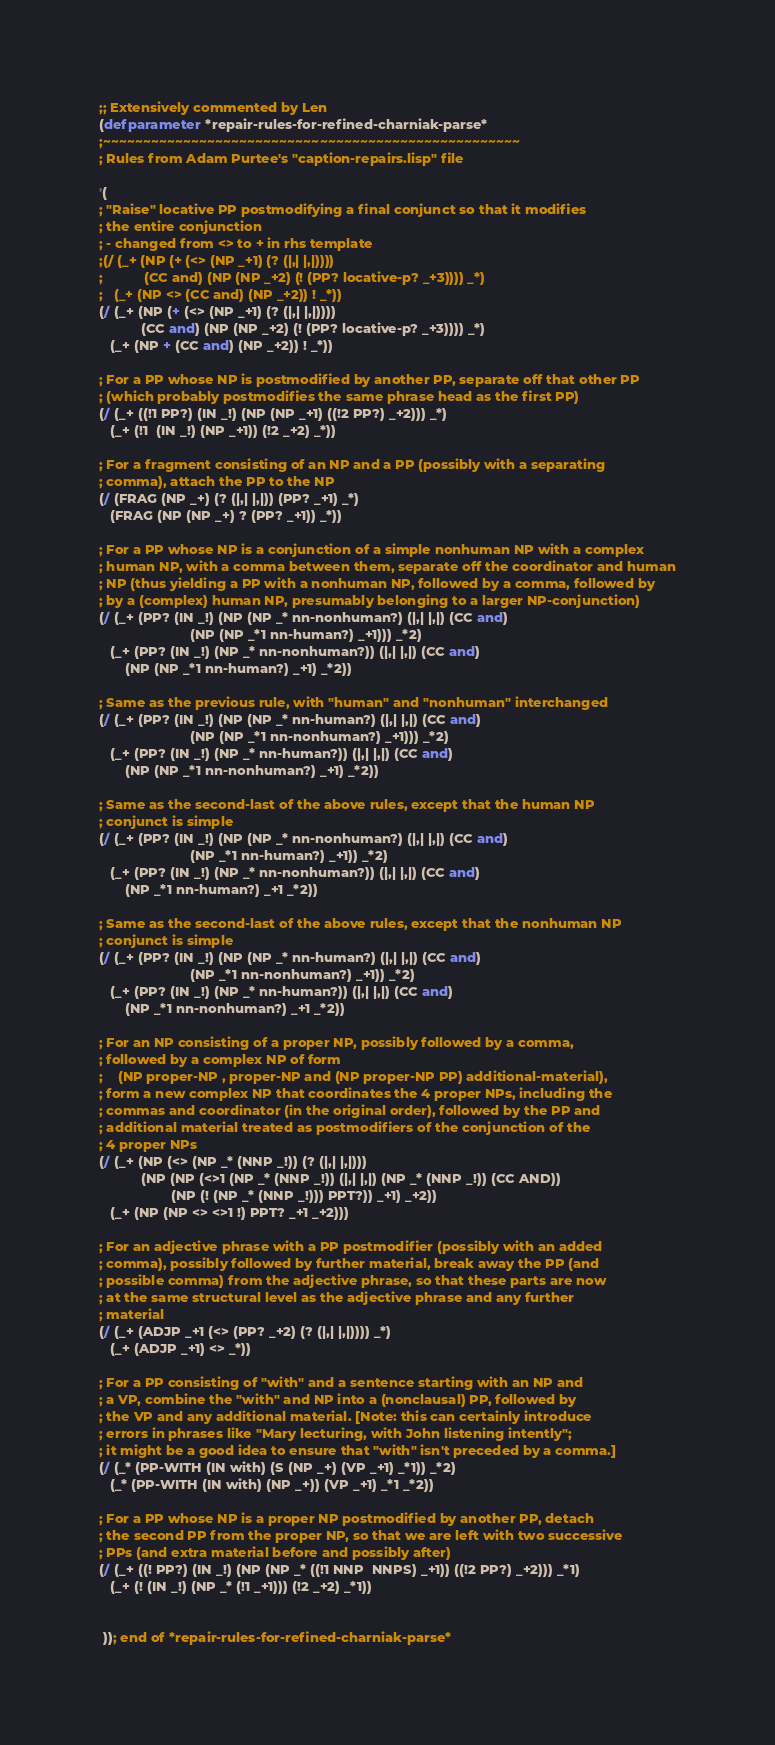<code> <loc_0><loc_0><loc_500><loc_500><_Lisp_>;; Extensively commented by Len 
(defparameter *repair-rules-for-refined-charniak-parse*
;~~~~~~~~~~~~~~~~~~~~~~~~~~~~~~~~~~~~~~~~~~~~~~~~~~~~
; Rules from Adam Purtee's "caption-repairs.lisp" file

'(
; "Raise" locative PP postmodifying a final conjunct so that it modifies
; the entire conjunction 
; - changed from <> to + in rhs template
;(/ (_+ (NP (+ (<> (NP _+1) (? (|,| |,|)))) 
;           (CC and) (NP (NP _+2) (! (PP? locative-p? _+3)))) _*) 
;   (_+ (NP <> (CC and) (NP _+2)) ! _*))
(/ (_+ (NP (+ (<> (NP _+1) (? (|,| |,|)))) 
           (CC and) (NP (NP _+2) (! (PP? locative-p? _+3)))) _*) 
   (_+ (NP + (CC and) (NP _+2)) ! _*))

; For a PP whose NP is postmodified by another PP, separate off that other PP
; (which probably postmodifies the same phrase head as the first PP)
(/ (_+ ((!1 PP?) (IN _!) (NP (NP _+1) ((!2 PP?) _+2))) _*) 
   (_+ (!1  (IN _!) (NP _+1)) (!2 _+2) _*))

; For a fragment consisting of an NP and a PP (possibly with a separating
; comma), attach the PP to the NP
(/ (FRAG (NP _+) (? (|,| |,|)) (PP? _+1) _*)
   (FRAG (NP (NP _+) ? (PP? _+1)) _*))

; For a PP whose NP is a conjunction of a simple nonhuman NP with a complex 
; human NP, with a comma between them, separate off the coordinator and human
; NP (thus yielding a PP with a nonhuman NP, followed by a comma, followed by
; by a (complex) human NP, presumably belonging to a larger NP-conjunction) 
(/ (_+ (PP? (IN _!) (NP (NP _* nn-nonhuman?) (|,| |,|) (CC and) 
                        (NP (NP _*1 nn-human?) _+1))) _*2) 
   (_+ (PP? (IN _!) (NP _* nn-nonhuman?)) (|,| |,|) (CC and) 
       (NP (NP _*1 nn-human?) _+1) _*2))

; Same as the previous rule, with "human" and "nonhuman" interchanged 
(/ (_+ (PP? (IN _!) (NP (NP _* nn-human?) (|,| |,|) (CC and) 
                        (NP (NP _*1 nn-nonhuman?) _+1))) _*2) 
   (_+ (PP? (IN _!) (NP _* nn-human?)) (|,| |,|) (CC and) 
       (NP (NP _*1 nn-nonhuman?) _+1) _*2))

; Same as the second-last of the above rules, except that the human NP
; conjunct is simple
(/ (_+ (PP? (IN _!) (NP (NP _* nn-nonhuman?) (|,| |,|) (CC and) 
                        (NP _*1 nn-human?) _+1)) _*2) 
   (_+ (PP? (IN _!) (NP _* nn-nonhuman?)) (|,| |,|) (CC and) 
       (NP _*1 nn-human?) _+1 _*2))

; Same as the second-last of the above rules, except that the nonhuman NP
; conjunct is simple
(/ (_+ (PP? (IN _!) (NP (NP _* nn-human?) (|,| |,|) (CC and) 
                        (NP _*1 nn-nonhuman?) _+1)) _*2) 
   (_+ (PP? (IN _!) (NP _* nn-human?)) (|,| |,|) (CC and) 
       (NP _*1 nn-nonhuman?) _+1 _*2))

; For an NP consisting of a proper NP, possibly followed by a comma, 
; followed by a complex NP of form 
;    (NP proper-NP , proper-NP and (NP proper-NP PP) additional-material),
; form a new complex NP that coordinates the 4 proper NPs, including the
; commas and coordinator (in the original order), followed by the PP and
; additional material treated as postmodifiers of the conjunction of the
; 4 proper NPs
(/ (_+ (NP (<> (NP _* (NNP _!)) (? (|,| |,|))) 
           (NP (NP (<>1 (NP _* (NNP _!)) (|,| |,|) (NP _* (NNP _!)) (CC AND)) 
                   (NP (! (NP _* (NNP _!))) PPT?)) _+1) _+2)) 
   (_+ (NP (NP <> <>1 !) PPT? _+1 _+2)))

; For an adjective phrase with a PP postmodifier (possibly with an added
; comma), possibly followed by further material, break away the PP (and
; possible comma) from the adjective phrase, so that these parts are now
; at the same structural level as the adjective phrase and any further
; material
(/ (_+ (ADJP _+1 (<> (PP? _+2) (? (|,| |,|)))) _*) 
   (_+ (ADJP _+1) <> _*))

; For a PP consisting of "with" and a sentence starting with an NP and
; a VP, combine the "with" and NP into a (nonclausal) PP, followed by
; the VP and any additional material. [Note: this can certainly introduce
; errors in phrases like "Mary lecturing, with John listening intently";
; it might be a good idea to ensure that "with" isn't preceded by a comma.]
(/ (_* (PP-WITH (IN with) (S (NP _+) (VP _+1) _*1)) _*2) 
   (_* (PP-WITH (IN with) (NP _+)) (VP _+1) _*1 _*2))

; For a PP whose NP is a proper NP postmodified by another PP, detach
; the second PP from the proper NP, so that we are left with two successive
; PPs (and extra material before and possibly after)
(/ (_+ ((! PP?) (IN _!) (NP (NP _* ((!1 NNP  NNPS) _+1)) ((!2 PP?) _+2))) _*1) 
   (_+ (! (IN _!) (NP _* (!1 _+1))) (!2 _+2) _*1))


 )); end of *repair-rules-for-refined-charniak-parse*
</code> 